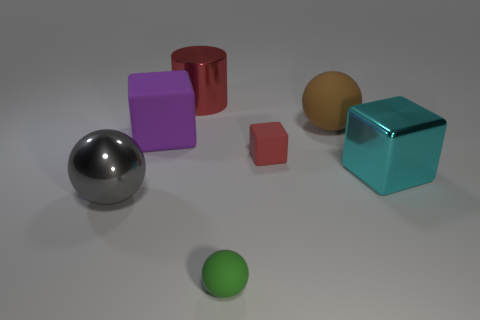Can you tell me about the different shapes and their colors in this image? Certainly! The image showcases a variety of geometric shapes, including a silver sphere, a red cylinder, a purple cube, a gold-colored sphere, a small pink cube, a large teal cube, and a small green sphere. The arrangement and the different colors make it a visually stimulating scene, possibly used for graphical rendering tests. 